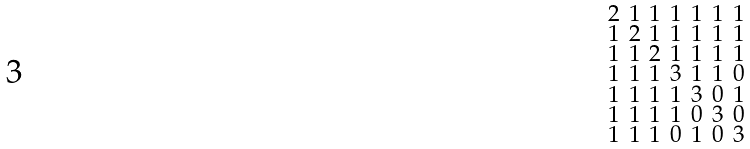Convert formula to latex. <formula><loc_0><loc_0><loc_500><loc_500>\begin{smallmatrix} 2 & 1 & 1 & 1 & 1 & 1 & 1 \\ 1 & 2 & 1 & 1 & 1 & 1 & 1 \\ 1 & 1 & 2 & 1 & 1 & 1 & 1 \\ 1 & 1 & 1 & 3 & 1 & 1 & 0 \\ 1 & 1 & 1 & 1 & 3 & 0 & 1 \\ 1 & 1 & 1 & 1 & 0 & 3 & 0 \\ 1 & 1 & 1 & 0 & 1 & 0 & 3 \end{smallmatrix}</formula> 